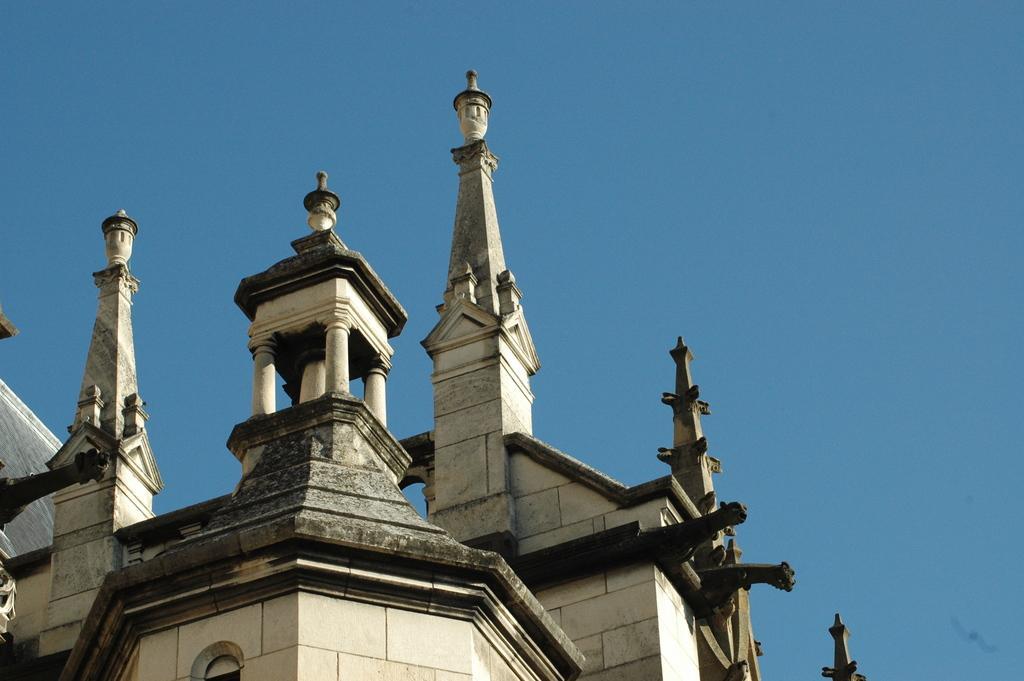Describe this image in one or two sentences. In the image there is an architecture. 